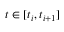<formula> <loc_0><loc_0><loc_500><loc_500>t \in [ t _ { i } , t _ { i + 1 } ]</formula> 